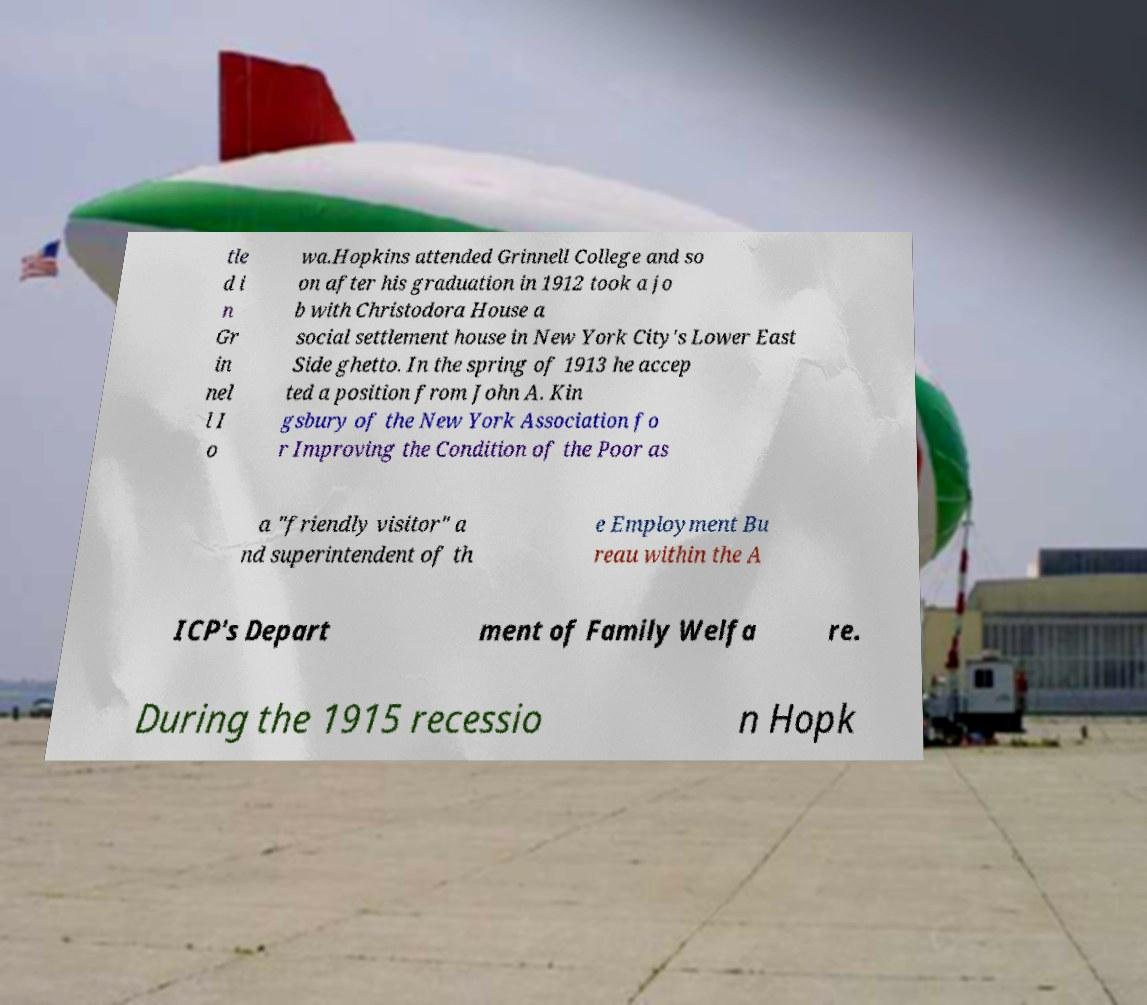There's text embedded in this image that I need extracted. Can you transcribe it verbatim? tle d i n Gr in nel l I o wa.Hopkins attended Grinnell College and so on after his graduation in 1912 took a jo b with Christodora House a social settlement house in New York City's Lower East Side ghetto. In the spring of 1913 he accep ted a position from John A. Kin gsbury of the New York Association fo r Improving the Condition of the Poor as a "friendly visitor" a nd superintendent of th e Employment Bu reau within the A ICP's Depart ment of Family Welfa re. During the 1915 recessio n Hopk 